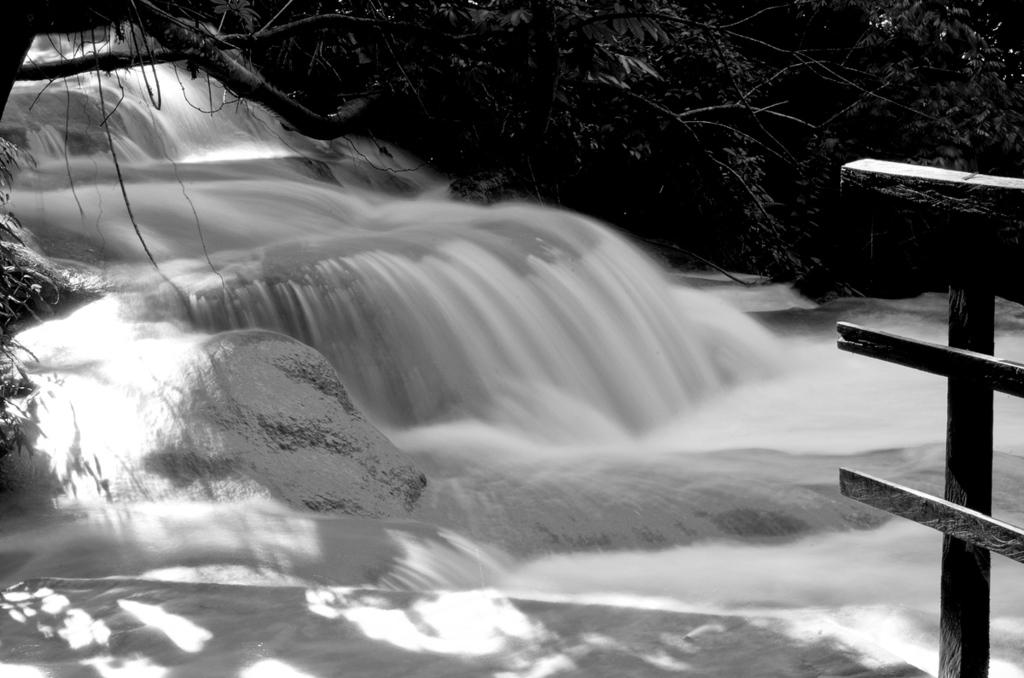What is happening in the image? Water is flowing in the image. Where is the fence located in the image? The fence is in the right corner of the image. What can be seen in the background of the image? Trees are present in the background of the image. What scent can be detected from the babies in the image? There are no babies present in the image, so no scent can be detected. 